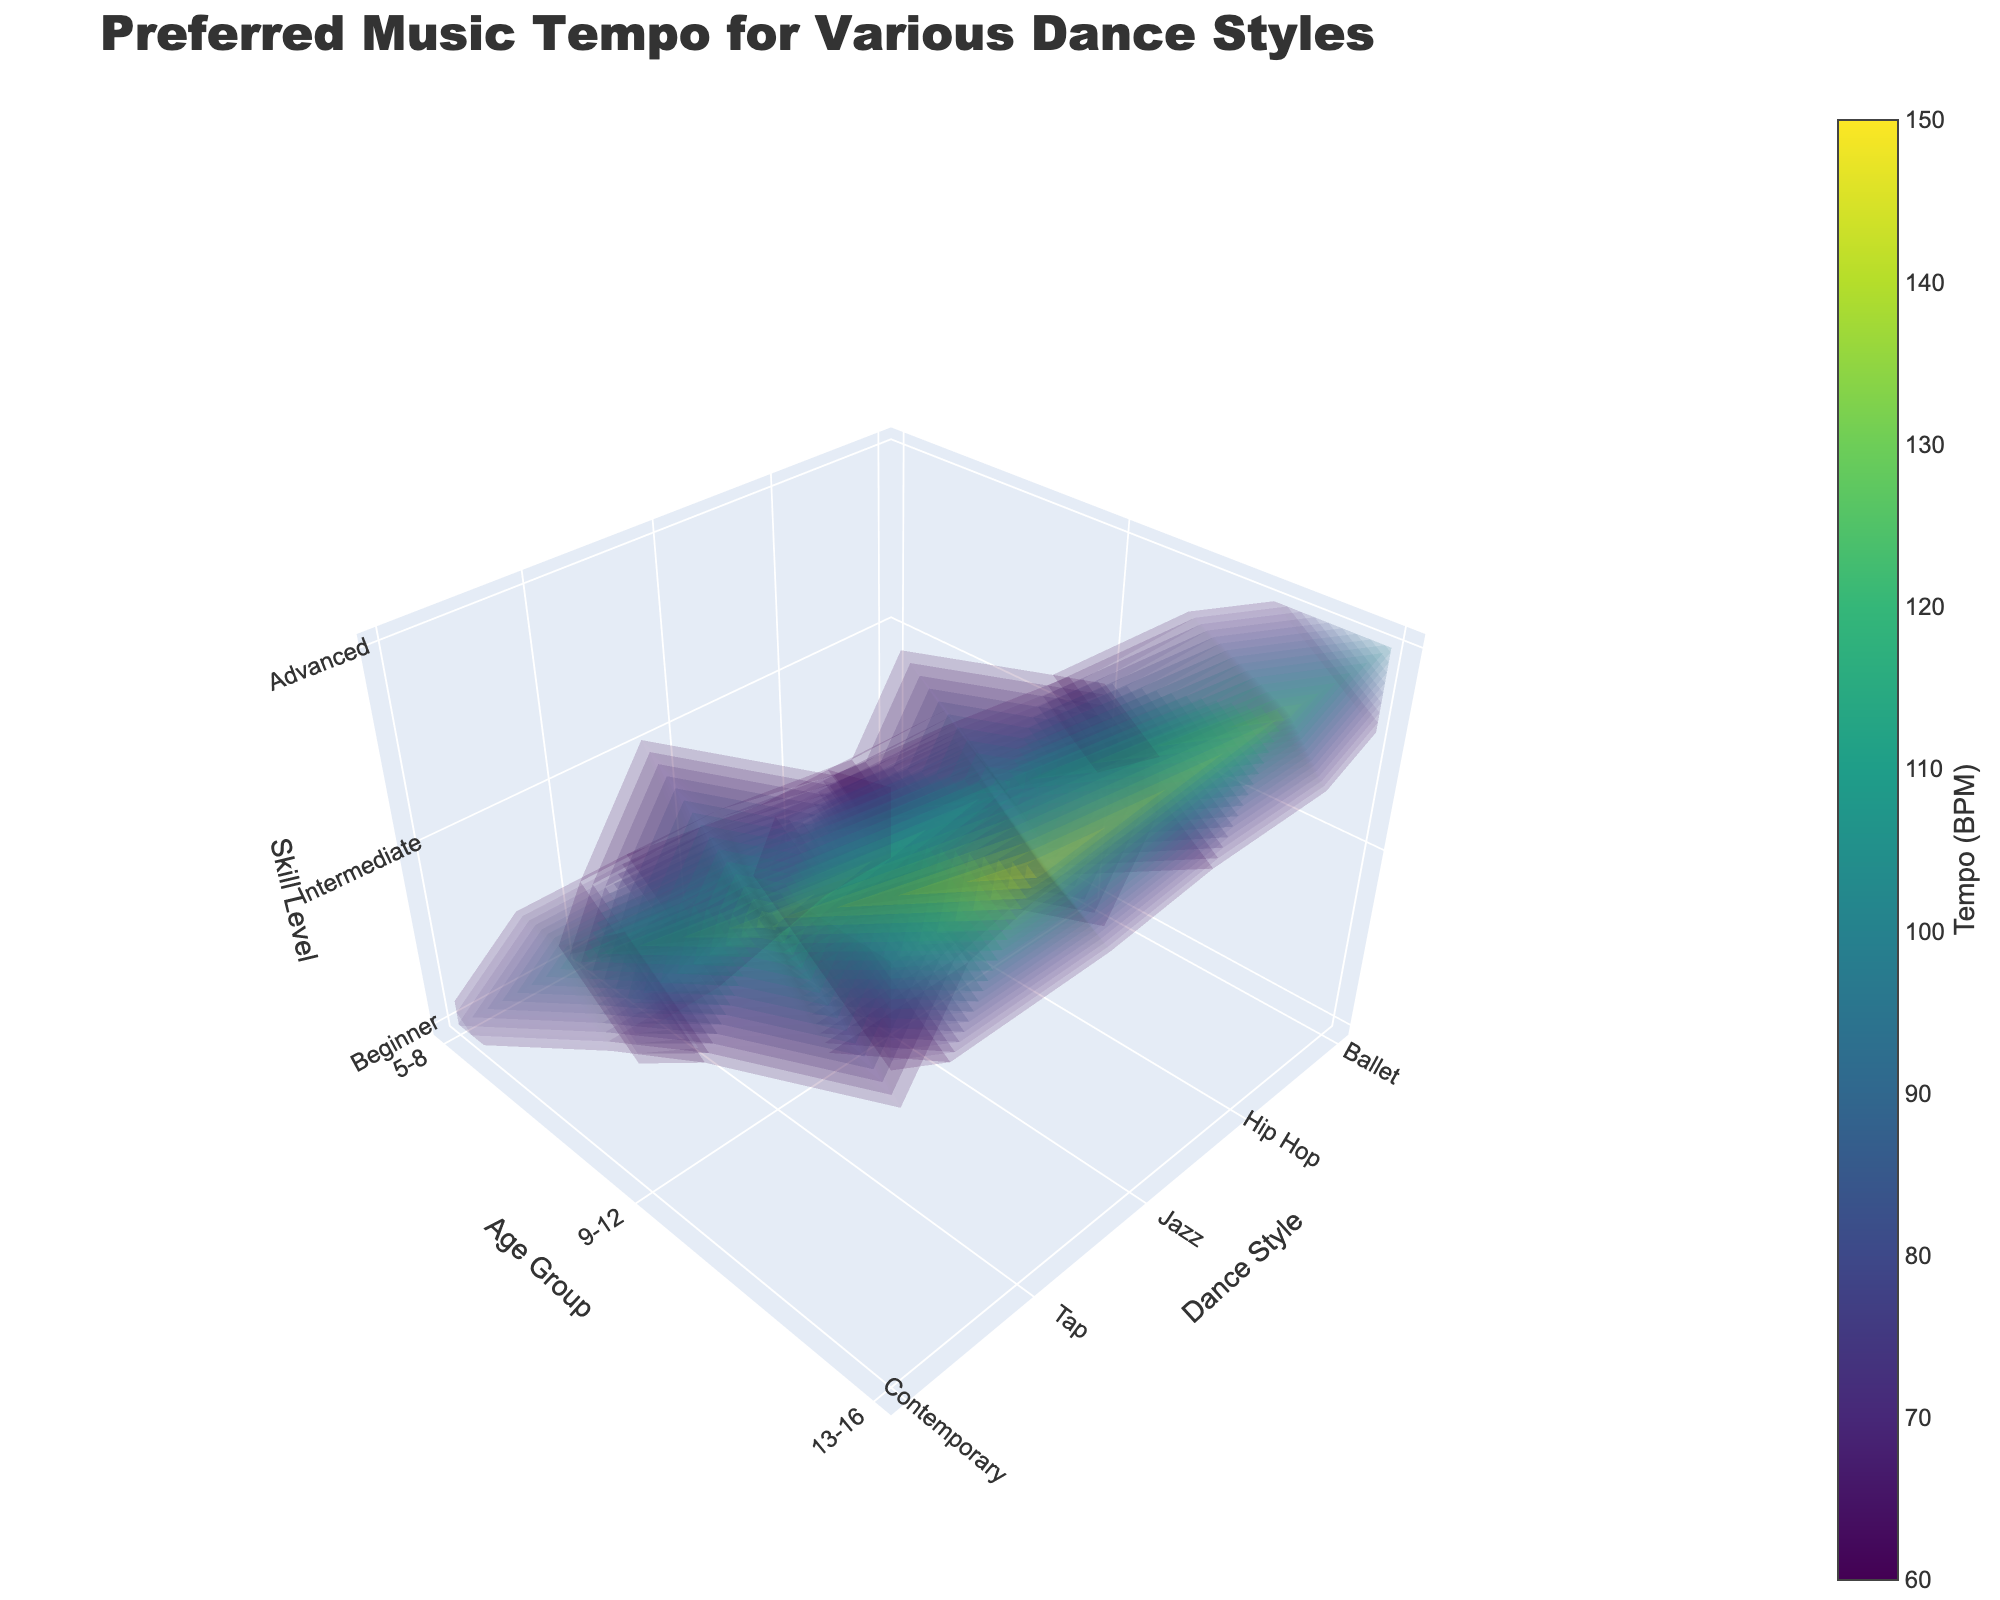What is the title of the figure? The title of the figure is typically displayed at the top of the chart. It shows the main topic or subject that the plot is representing. Here, the title is clearly stated.
Answer: Preferred Music Tempo for Various Dance Styles Which dance style has the highest preferred tempo at the advanced skill level for the 13-16 age group? To find this, look at the point corresponding to the 13-16 age group and the advanced skill level on the plot. Then, check which of the dance styles has the highest tempo value.
Answer: Tap What is the preferred tempo for intermediate ballet dancers aged 9-12? Navigate to the section of the plot where the dance style is Ballet, the age group is 9-12, and the skill level is Intermediate. The corresponding tempo value is then noted.
Answer: 80 BPM Compare the preferred tempos for beginner dancers in ballet and hip-hop for the 5-8 age group. Which one is higher? Locate the points for Ballet and Hip Hop in the 5-8 age group at the beginner skill level. Compare the tempo values to determine which one is higher.
Answer: Hip Hop Which dance style exhibits the largest increase in preferred tempo from beginner to advanced skill levels in the 13-16 age group? Compare the tempo values for all dance styles at beginner and advanced skill levels in the 13-16 age group and calculate the differences. Identify which dance style has the largest difference.
Answer: Tap What is the color scale used in the figure? The color scale indicates the range of tempo values using different colors. In this plot, observe the gradient near the color bar to identify the color scale.
Answer: Viridis What is the preferred tempo range for contemporary dance across all age groups and skill levels? Review the plot for all data points pertaining to Contemporary Dance and identify the minimum and maximum tempo values.
Answer: 70-110 BPM How does the preferred tempo for intermediate tap dancers aged 9-12 compare to intermediate jazz dancers in the same age group? Identify the tempo values for both Tap and Jazz at the intermediate skill level for the 9-12 age group. Compare these values to see which is greater.
Answer: Tap is higher Calculate the average preferred tempo for hip-hop dancers across all age groups and skill levels. Sum up the tempo values for Hip Hop at all age groups and skill levels: (90 + 110 + 130). Divide this total by the number of data points (3).
Answer: 110 BPM 